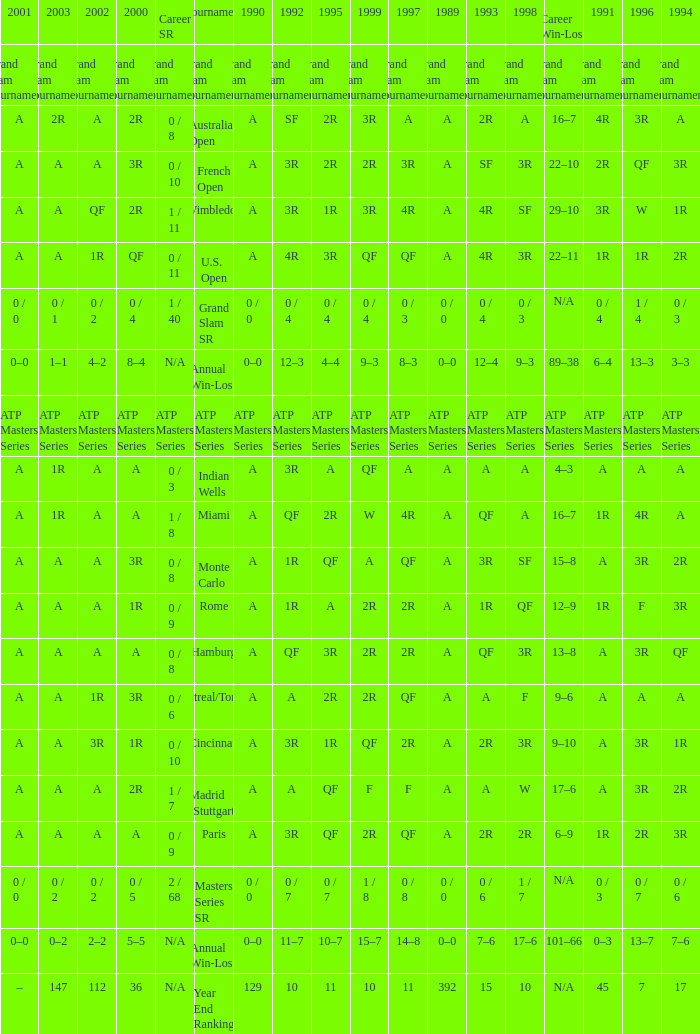What were the career sr values for a in 1980 and for f in 1997? 1 / 7. Would you mind parsing the complete table? {'header': ['2001', '2003', '2002', '2000', 'Career SR', 'Tournament', '1990', '1992', '1995', '1999', '1997', '1989', '1993', '1998', 'Career Win-Loss', '1991', '1996', '1994'], 'rows': [['Grand Slam Tournaments', 'Grand Slam Tournaments', 'Grand Slam Tournaments', 'Grand Slam Tournaments', 'Grand Slam Tournaments', 'Grand Slam Tournaments', 'Grand Slam Tournaments', 'Grand Slam Tournaments', 'Grand Slam Tournaments', 'Grand Slam Tournaments', 'Grand Slam Tournaments', 'Grand Slam Tournaments', 'Grand Slam Tournaments', 'Grand Slam Tournaments', 'Grand Slam Tournaments', 'Grand Slam Tournaments', 'Grand Slam Tournaments', 'Grand Slam Tournaments'], ['A', '2R', 'A', '2R', '0 / 8', 'Australian Open', 'A', 'SF', '2R', '3R', 'A', 'A', '2R', 'A', '16–7', '4R', '3R', 'A'], ['A', 'A', 'A', '3R', '0 / 10', 'French Open', 'A', '3R', '2R', '2R', '3R', 'A', 'SF', '3R', '22–10', '2R', 'QF', '3R'], ['A', 'A', 'QF', '2R', '1 / 11', 'Wimbledon', 'A', '3R', '1R', '3R', '4R', 'A', '4R', 'SF', '29–10', '3R', 'W', '1R'], ['A', 'A', '1R', 'QF', '0 / 11', 'U.S. Open', 'A', '4R', '3R', 'QF', 'QF', 'A', '4R', '3R', '22–11', '1R', '1R', '2R'], ['0 / 0', '0 / 1', '0 / 2', '0 / 4', '1 / 40', 'Grand Slam SR', '0 / 0', '0 / 4', '0 / 4', '0 / 4', '0 / 3', '0 / 0', '0 / 4', '0 / 3', 'N/A', '0 / 4', '1 / 4', '0 / 3'], ['0–0', '1–1', '4–2', '8–4', 'N/A', 'Annual Win-Loss', '0–0', '12–3', '4–4', '9–3', '8–3', '0–0', '12–4', '9–3', '89–38', '6–4', '13–3', '3–3'], ['ATP Masters Series', 'ATP Masters Series', 'ATP Masters Series', 'ATP Masters Series', 'ATP Masters Series', 'ATP Masters Series', 'ATP Masters Series', 'ATP Masters Series', 'ATP Masters Series', 'ATP Masters Series', 'ATP Masters Series', 'ATP Masters Series', 'ATP Masters Series', 'ATP Masters Series', 'ATP Masters Series', 'ATP Masters Series', 'ATP Masters Series', 'ATP Masters Series'], ['A', '1R', 'A', 'A', '0 / 3', 'Indian Wells', 'A', '3R', 'A', 'QF', 'A', 'A', 'A', 'A', '4–3', 'A', 'A', 'A'], ['A', '1R', 'A', 'A', '1 / 8', 'Miami', 'A', 'QF', '2R', 'W', '4R', 'A', 'QF', 'A', '16–7', '1R', '4R', 'A'], ['A', 'A', 'A', '3R', '0 / 8', 'Monte Carlo', 'A', '1R', 'QF', 'A', 'QF', 'A', '3R', 'SF', '15–8', 'A', '3R', '2R'], ['A', 'A', 'A', '1R', '0 / 9', 'Rome', 'A', '1R', 'A', '2R', '2R', 'A', '1R', 'QF', '12–9', '1R', 'F', '3R'], ['A', 'A', 'A', 'A', '0 / 8', 'Hamburg', 'A', 'QF', '3R', '2R', '2R', 'A', 'QF', '3R', '13–8', 'A', '3R', 'QF'], ['A', 'A', '1R', '3R', '0 / 6', 'Montreal/Toronto', 'A', 'A', '2R', '2R', 'QF', 'A', 'A', 'F', '9–6', 'A', 'A', 'A'], ['A', 'A', '3R', '1R', '0 / 10', 'Cincinnati', 'A', '3R', '1R', 'QF', '2R', 'A', '2R', '3R', '9–10', 'A', '3R', '1R'], ['A', 'A', 'A', '2R', '1 / 7', 'Madrid (Stuttgart)', 'A', 'A', 'QF', 'F', 'F', 'A', 'A', 'W', '17–6', 'A', '3R', '2R'], ['A', 'A', 'A', 'A', '0 / 9', 'Paris', 'A', '3R', 'QF', '2R', 'QF', 'A', '2R', '2R', '6–9', '1R', '2R', '3R'], ['0 / 0', '0 / 2', '0 / 2', '0 / 5', '2 / 68', 'Masters Series SR', '0 / 0', '0 / 7', '0 / 7', '1 / 8', '0 / 8', '0 / 0', '0 / 6', '1 / 7', 'N/A', '0 / 3', '0 / 7', '0 / 6'], ['0–0', '0–2', '2–2', '5–5', 'N/A', 'Annual Win-Loss', '0–0', '11–7', '10–7', '15–7', '14–8', '0–0', '7–6', '17–6', '101–66', '0–3', '13–7', '7–6'], ['–', '147', '112', '36', 'N/A', 'Year End Ranking', '129', '10', '11', '10', '11', '392', '15', '10', 'N/A', '45', '7', '17']]} 